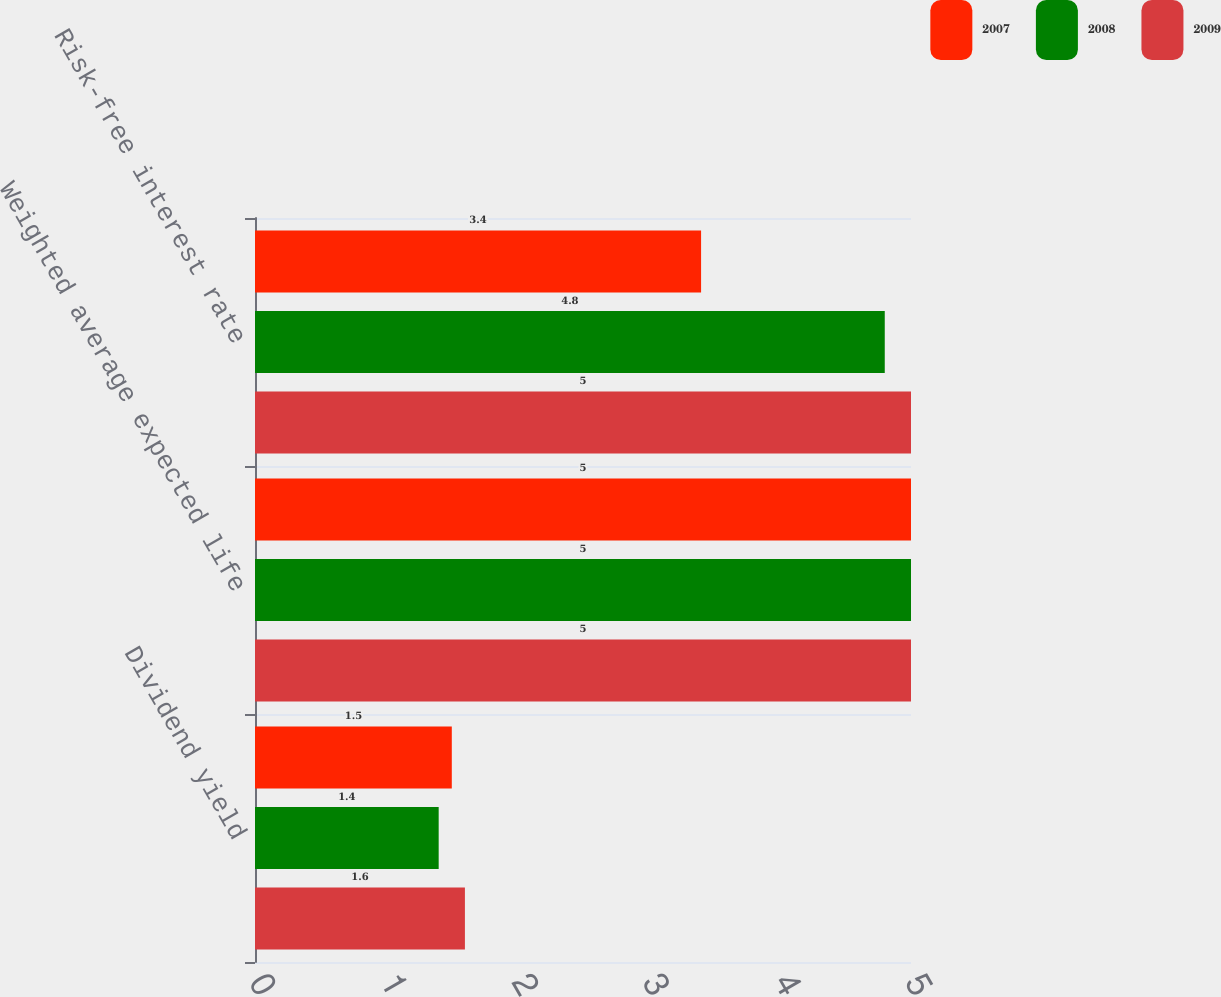Convert chart. <chart><loc_0><loc_0><loc_500><loc_500><stacked_bar_chart><ecel><fcel>Dividend yield<fcel>Weighted average expected life<fcel>Risk-free interest rate<nl><fcel>2007<fcel>1.5<fcel>5<fcel>3.4<nl><fcel>2008<fcel>1.4<fcel>5<fcel>4.8<nl><fcel>2009<fcel>1.6<fcel>5<fcel>5<nl></chart> 